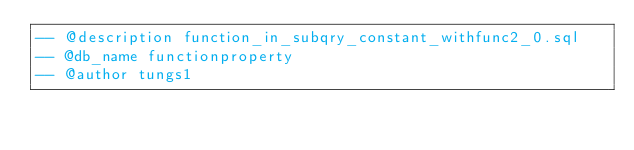Convert code to text. <code><loc_0><loc_0><loc_500><loc_500><_SQL_>-- @description function_in_subqry_constant_withfunc2_0.sql
-- @db_name functionproperty
-- @author tungs1</code> 